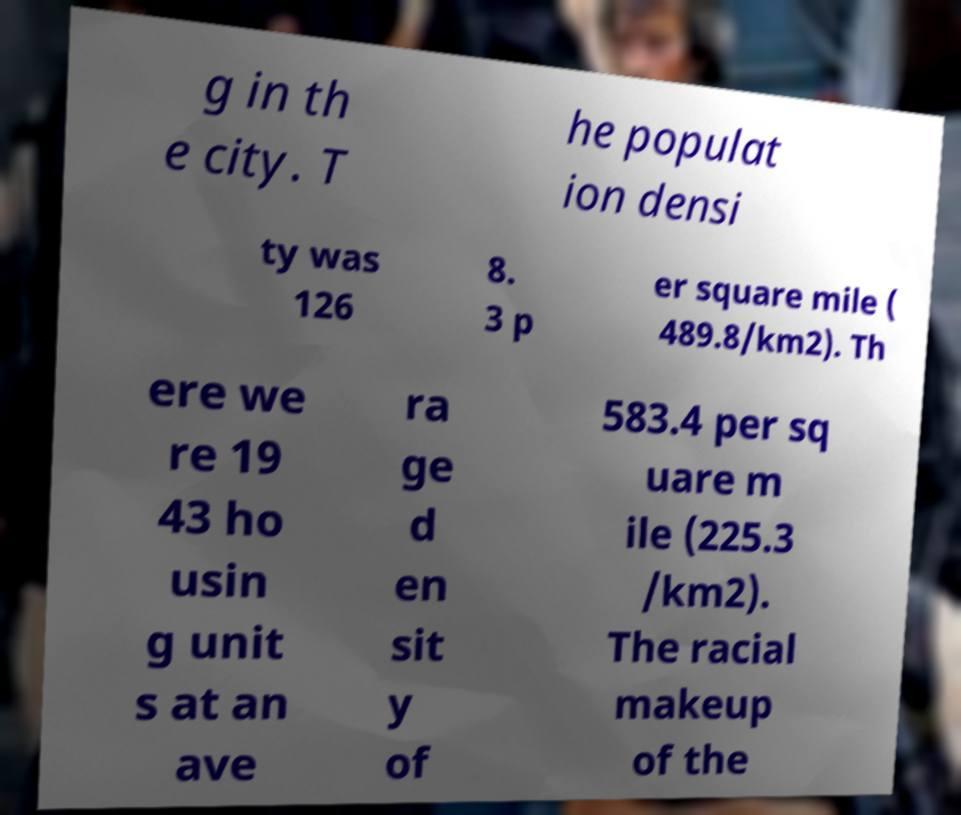What messages or text are displayed in this image? I need them in a readable, typed format. g in th e city. T he populat ion densi ty was 126 8. 3 p er square mile ( 489.8/km2). Th ere we re 19 43 ho usin g unit s at an ave ra ge d en sit y of 583.4 per sq uare m ile (225.3 /km2). The racial makeup of the 